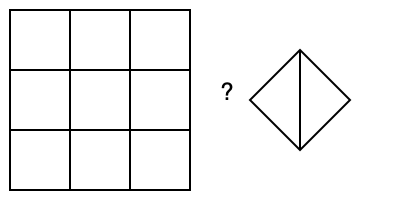Which 3D shape would result from folding the 2D net shown on the left along the marked lines? To solve this problem, let's follow these steps:

1. Analyze the 2D net:
   - The net is a square divided into 9 equal smaller squares.

2. Identify the folding lines:
   - There are 4 folding lines: 2 horizontal and 2 vertical.

3. Visualize the folding process:
   - The outer squares will fold up to form the sides of a 3D shape.
   - The central square will remain as the base.

4. Determine the resulting 3D shape:
   - With 4 equal sides folding up from a square base, we get a cube.

5. Compare with the given shape:
   - The shape on the right is not a cube, but a square-based pyramid.
   - A pyramid has triangular sides meeting at a point, unlike a cube with square sides.

6. Conclusion:
   - The given 3D shape does not match the folded result of the 2D net.

Therefore, the 3D shape shown is not the correct result of folding the given 2D net.
Answer: No 